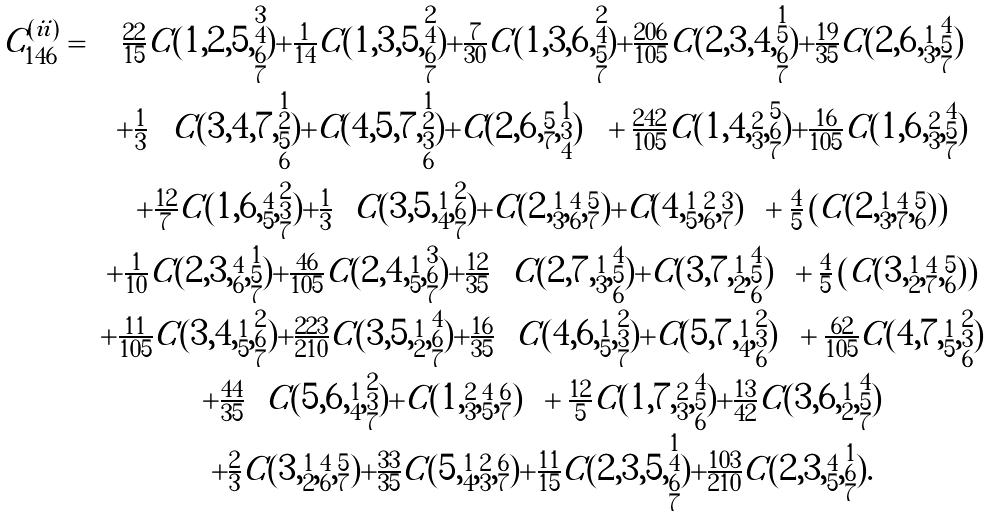Convert formula to latex. <formula><loc_0><loc_0><loc_500><loc_500>\begin{array} { r c } C ^ { ( i i ) } _ { 1 4 6 } = & \frac { 2 2 } { 1 5 } C ( 1 , 2 , 5 , \substack { 3 \\ 4 \\ 6 \\ 7 } ) + \frac { 1 } { 1 4 } C ( 1 , 3 , 5 , \substack { 2 \\ 4 \\ 6 \\ 7 } ) + \frac { 7 } { 3 0 } C ( 1 , 3 , 6 , \substack { 2 \\ 4 \\ 5 \\ 7 } ) + \frac { 2 0 6 } { 1 0 5 } C ( 2 , 3 , 4 , \substack { 1 \\ 5 \\ 6 \\ 7 } ) + \frac { 1 9 } { 3 5 } C ( 2 , 6 , \substack { 1 \\ 3 } , \substack { 4 \\ 5 \\ 7 } ) \\ & + \frac { 1 } { 3 } \left ( C ( 3 , 4 , 7 , \substack { 1 \\ 2 \\ 5 \\ 6 } ) + C ( 4 , 5 , 7 , \substack { 1 \\ 2 \\ 3 \\ 6 } ) + C ( 2 , 6 , \substack { 5 \\ 7 } , \substack { 1 \\ 3 \\ 4 } ) \right ) + \frac { 2 4 2 } { 1 0 5 } C ( 1 , 4 , \substack { 2 \\ 3 } , \substack { 5 \\ 6 \\ 7 } ) + \frac { 1 6 } { 1 0 5 } C ( 1 , 6 , \substack { 2 \\ 3 } , \substack { 4 \\ 5 \\ 7 } ) \\ & + \frac { 1 2 } { 7 } C ( 1 , 6 , \substack { 4 \\ 5 } , \substack { 2 \\ 3 \\ 7 } ) + \frac { 1 } { 3 } \left ( C ( 3 , 5 , \substack { 1 \\ 4 } , \substack { 2 \\ 6 \\ 7 } ) + C ( 2 , \substack { 1 \\ 3 } , \substack { 4 \\ 6 } , \substack { 5 \\ 7 } ) + C ( 4 , \substack { 1 \\ 5 } , \substack { 2 \\ 6 } , \substack { 3 \\ 7 } ) \right ) + \frac { 4 } { 5 } \left ( C ( 2 , \substack { 1 \\ 3 } , \substack { 4 \\ 7 } , \substack { 5 \\ 6 } ) \right ) \\ & + \frac { 1 } { 1 0 } C ( 2 , 3 , \substack { 4 \\ 6 } , \substack { 1 \\ 5 \\ 7 } ) + \frac { 4 6 } { 1 0 5 } C ( 2 , 4 , \substack { 1 \\ 5 } , \substack { 3 \\ 6 \\ 7 } ) + \frac { 1 2 } { 3 5 } \left ( C ( 2 , 7 , \substack { 1 \\ 3 } , \substack { 4 \\ 5 \\ 6 } ) + C ( 3 , 7 , \substack { 1 \\ 2 } , \substack { 4 \\ 5 \\ 6 } ) \right ) + \frac { 4 } { 5 } \left ( C ( 3 , \substack { 1 \\ 2 } , \substack { 4 \\ 7 } , \substack { 5 \\ 6 } ) \right ) \\ & + \frac { 1 1 } { 1 0 5 } C ( 3 , 4 , \substack { 1 \\ 5 } , \substack { 2 \\ 6 \\ 7 } ) + \frac { 2 2 3 } { 2 1 0 } C ( 3 , 5 , \substack { 1 \\ 2 } , \substack { 4 \\ 6 \\ 7 } ) + \frac { 1 6 } { 3 5 } \left ( C ( 4 , 6 , \substack { 1 \\ 5 } , \substack { 2 \\ 3 \\ 7 } ) + C ( 5 , 7 , \substack { 1 \\ 4 } , \substack { 2 \\ 3 \\ 6 } ) \right ) + \frac { 6 2 } { 1 0 5 } C ( 4 , 7 , \substack { 1 \\ 5 } , \substack { 2 \\ 3 \\ 6 } ) \\ & + \frac { 4 4 } { 3 5 } \left ( C ( 5 , 6 , \substack { 1 \\ 4 } , \substack { 2 \\ 3 \\ 7 } ) + C ( 1 , \substack { 2 \\ 3 } , \substack { 4 \\ 5 } , \substack { 6 \\ 7 } ) \right ) + \frac { 1 2 } { 5 } C ( 1 , 7 , \substack { 2 \\ 3 } , \substack { 4 \\ 5 \\ 6 } ) + \frac { 1 3 } { 4 2 } C ( 3 , 6 , \substack { 1 \\ 2 } , \substack { 4 \\ 5 \\ 7 } ) \\ & + \frac { 2 } { 3 } C ( 3 , \substack { 1 \\ 2 } , \substack { 4 \\ 6 } , \substack { 5 \\ 7 } ) + \frac { 3 3 } { 3 5 } C ( 5 , \substack { 1 \\ 4 } , \substack { 2 \\ 3 } , \substack { 6 \\ 7 } ) + \frac { 1 1 } { 1 5 } C ( 2 , 3 , 5 , \substack { 1 \\ 4 \\ 6 \\ 7 } ) + \frac { 1 0 3 } { 2 1 0 } C ( 2 , 3 , \substack { 4 \\ 5 } , \substack { 1 \\ 6 \\ 7 } ) . \end{array}</formula> 